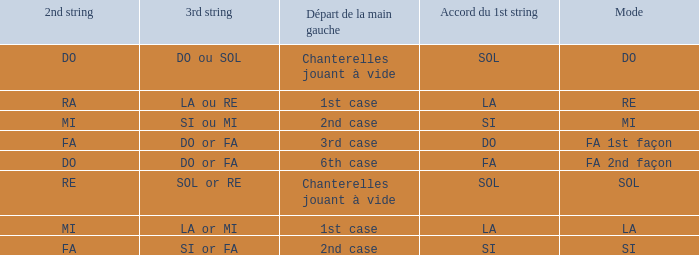What is the mode of the Depart de la main gauche of 1st case and a la or mi 3rd string? LA. 